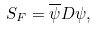<formula> <loc_0><loc_0><loc_500><loc_500>S _ { F } = \overline { \psi } D \psi ,</formula> 